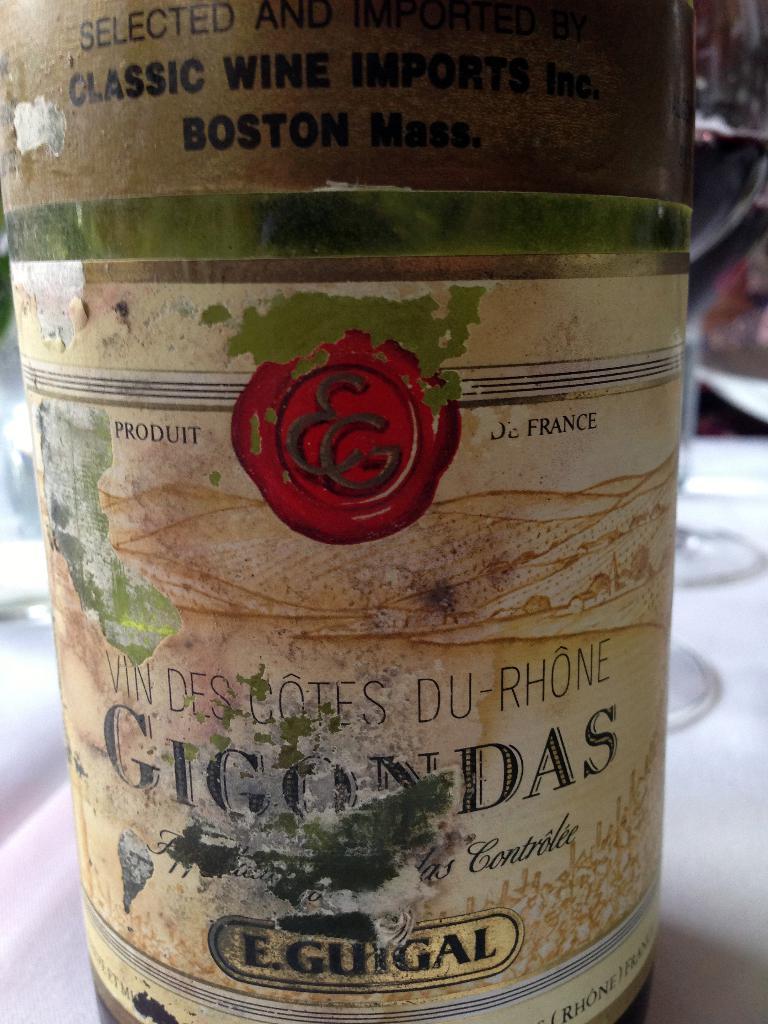What country was this made?
Provide a short and direct response. France. 